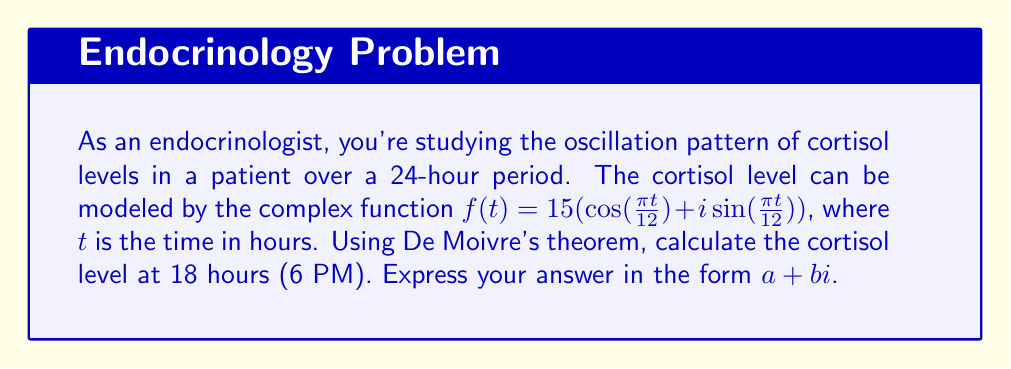Show me your answer to this math problem. To solve this problem, we'll use De Moivre's theorem and follow these steps:

1) De Moivre's theorem states that for any real number $x$ and integer $n$:

   $(\cos x + i\sin x)^n = \cos(nx) + i\sin(nx)$

2) In our case, the function is:

   $f(t) = 15(\cos(\frac{\pi t}{12}) + i\sin(\frac{\pi t}{12}))$

3) We need to find $f(18)$. Let's substitute $t = 18$:

   $f(18) = 15(\cos(\frac{18\pi}{12}) + i\sin(\frac{18\pi}{12}))$

4) Simplify the argument:

   $f(18) = 15(\cos(\frac{3\pi}{2}) + i\sin(\frac{3\pi}{2}))$

5) Recall the values of cosine and sine at $\frac{3\pi}{2}$:

   $\cos(\frac{3\pi}{2}) = 0$
   $\sin(\frac{3\pi}{2}) = -1$

6) Substitute these values:

   $f(18) = 15(0 + i(-1))$

7) Simplify:

   $f(18) = -15i$

Therefore, the cortisol level at 18 hours (6 PM) is $-15i$.
Answer: $0 - 15i$ 